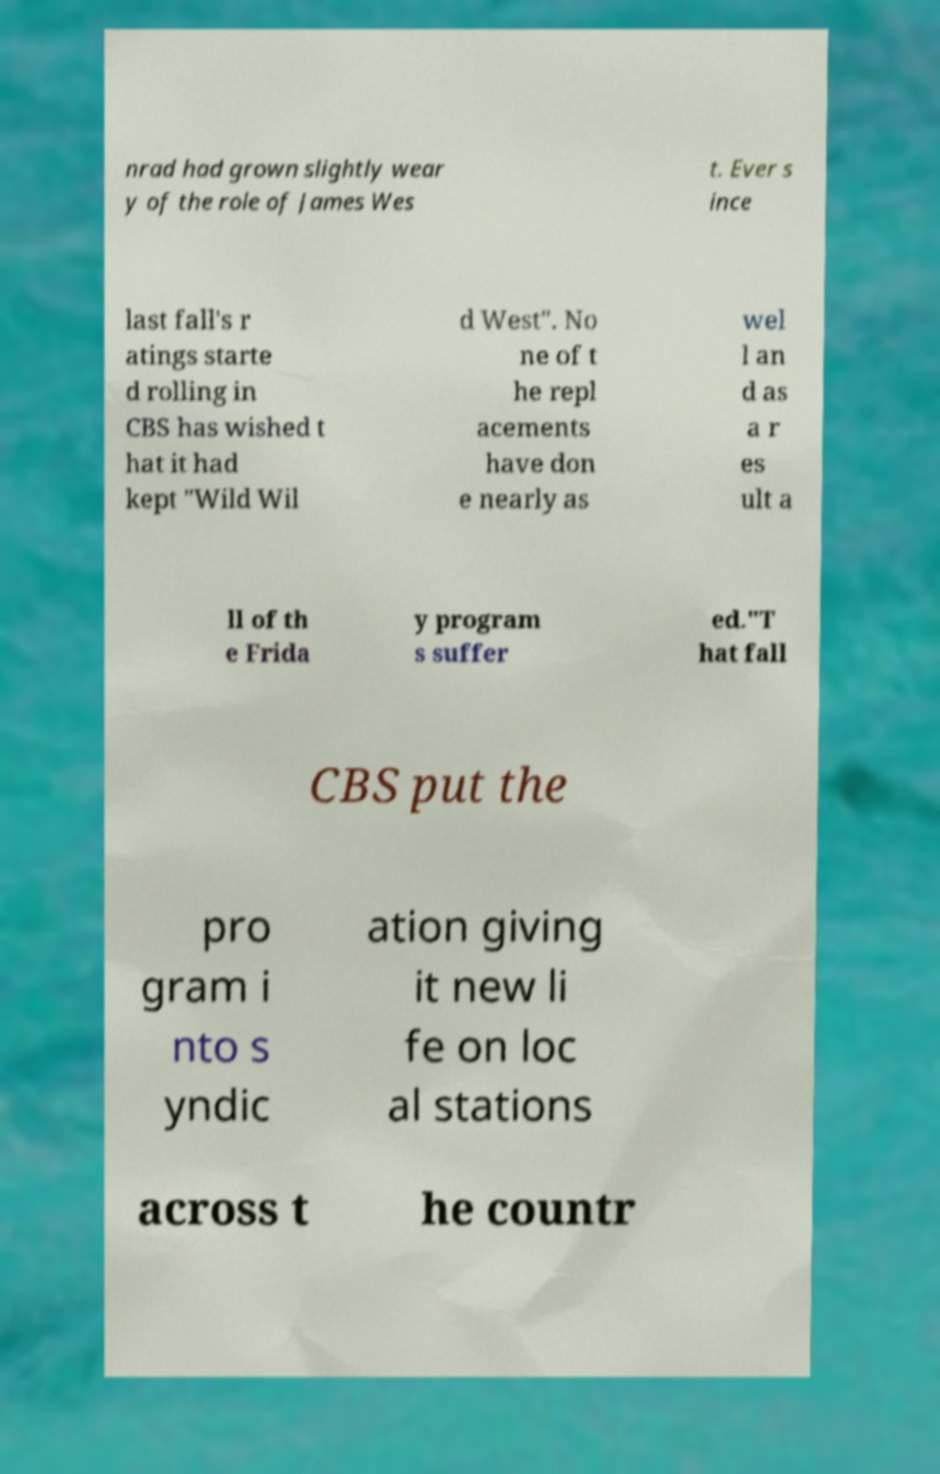Can you accurately transcribe the text from the provided image for me? nrad had grown slightly wear y of the role of James Wes t. Ever s ince last fall's r atings starte d rolling in CBS has wished t hat it had kept "Wild Wil d West". No ne of t he repl acements have don e nearly as wel l an d as a r es ult a ll of th e Frida y program s suffer ed."T hat fall CBS put the pro gram i nto s yndic ation giving it new li fe on loc al stations across t he countr 